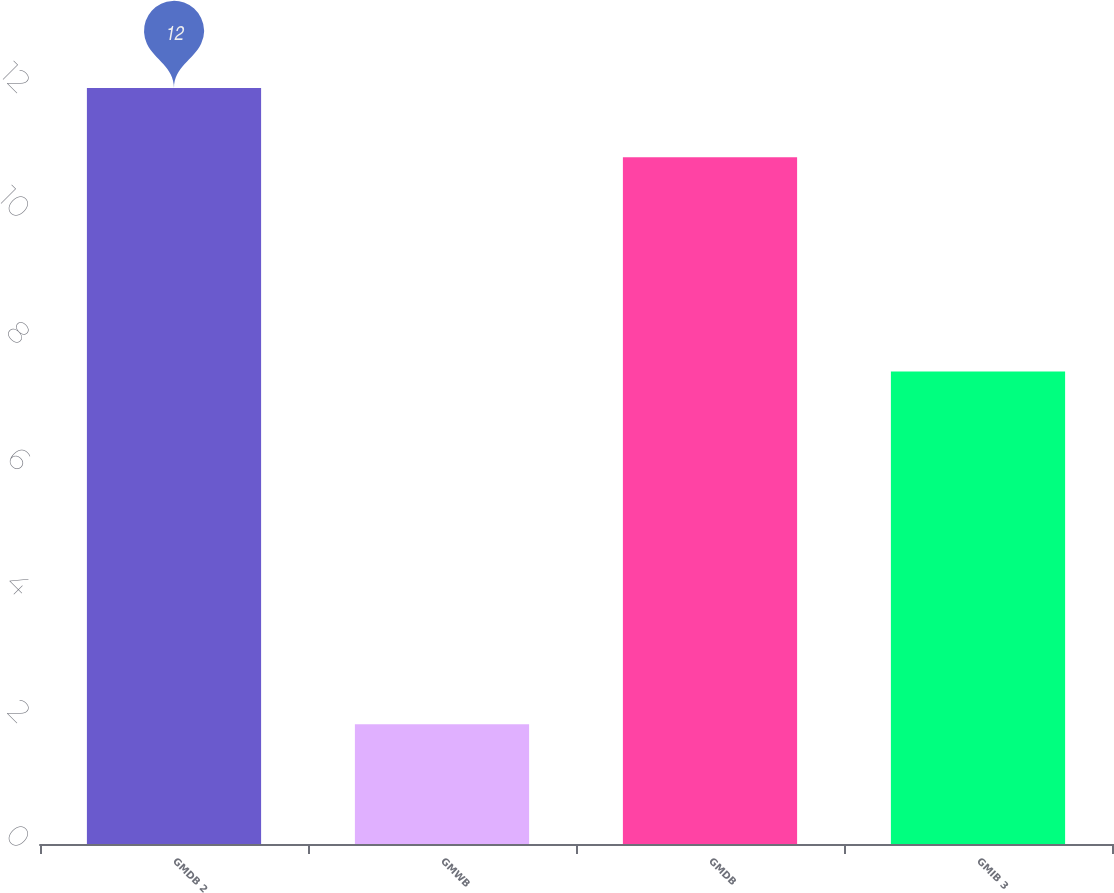<chart> <loc_0><loc_0><loc_500><loc_500><bar_chart><fcel>GMDB 2<fcel>GMWB<fcel>GMDB<fcel>GMIB 3<nl><fcel>12<fcel>1.9<fcel>10.9<fcel>7.5<nl></chart> 